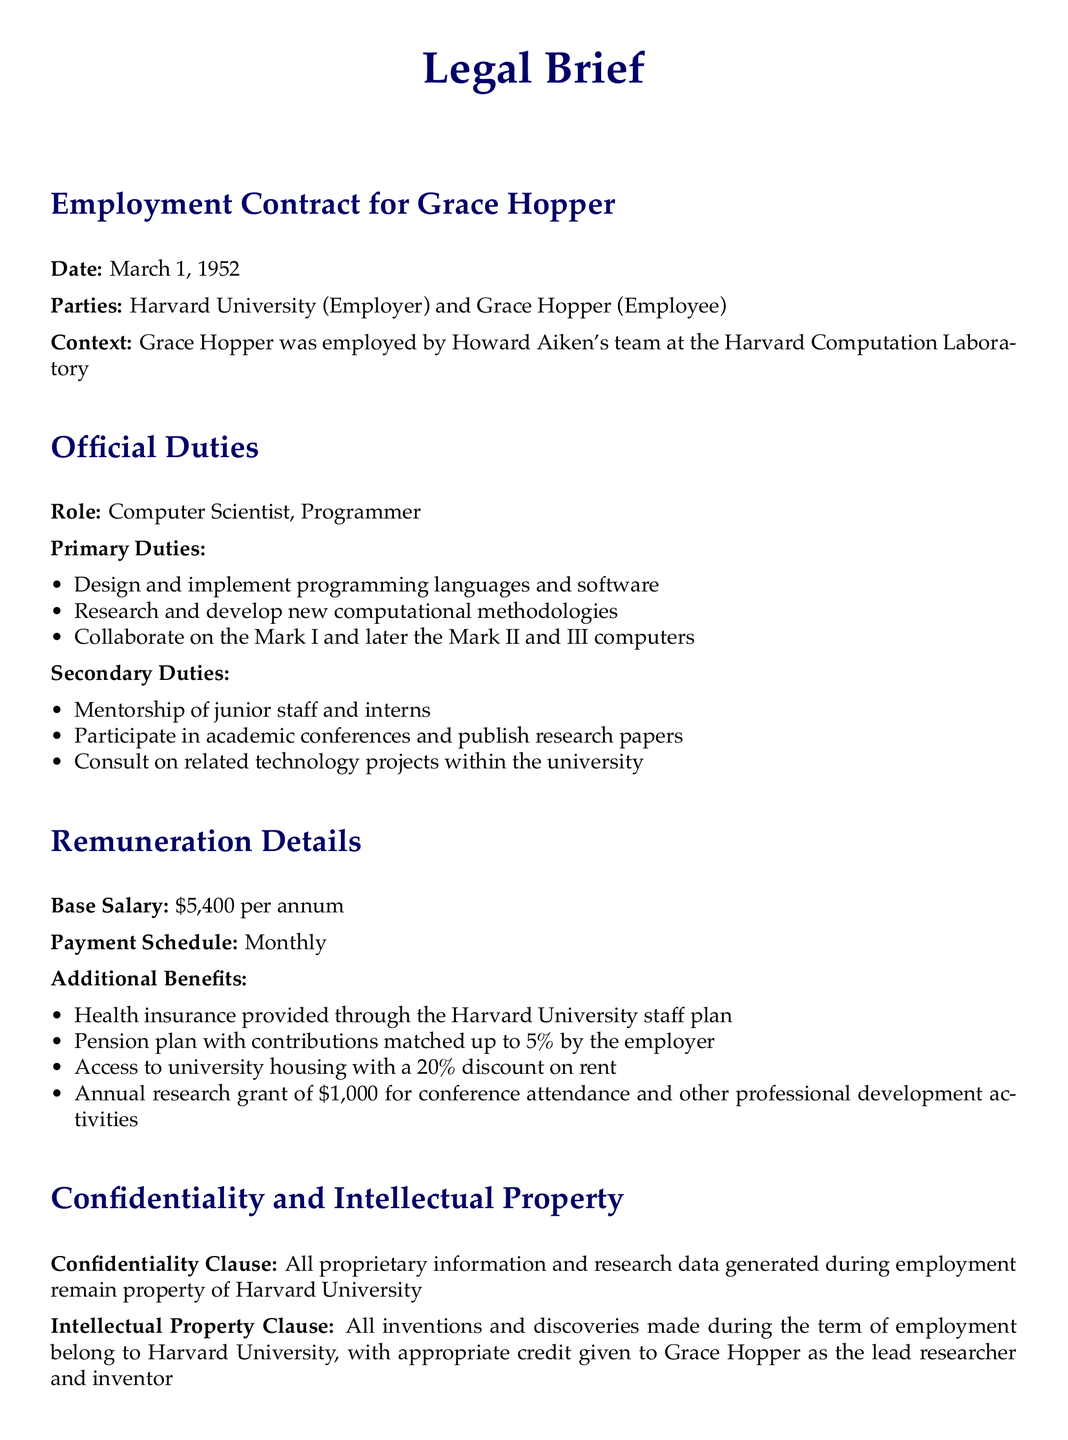What is the date of the employment contract? The date of the employment contract is explicitly stated in the document.
Answer: March 1, 1952 Who is the employer in this contract? The employer is clearly mentioned in the document.
Answer: Harvard University What is the base salary for Grace Hopper? The base salary is specified in the remuneration details section of the document.
Answer: $5,400 per annum What primary duty involves programming languages? The primary duties are listed, and one relates directly to programming languages.
Answer: Design and implement programming languages and software What additional benefit is related to health? The document outlines various benefits, including one concerning health.
Answer: Health insurance provided through the Harvard University staff plan What is the duration of the contract? The effective and expiration dates indicate the contract's duration.
Answer: Three years What is the maximum employer contribution percentage for the pension plan? The document details the employer's contribution terms for the pension plan.
Answer: 5% What is the confidentiality clause about? This clause indicates who owns the information generated during employment.
Answer: Property of Harvard University What is the expiration date of the contract? The expiration date is mentioned in the contract duration section.
Answer: February 28, 1955 